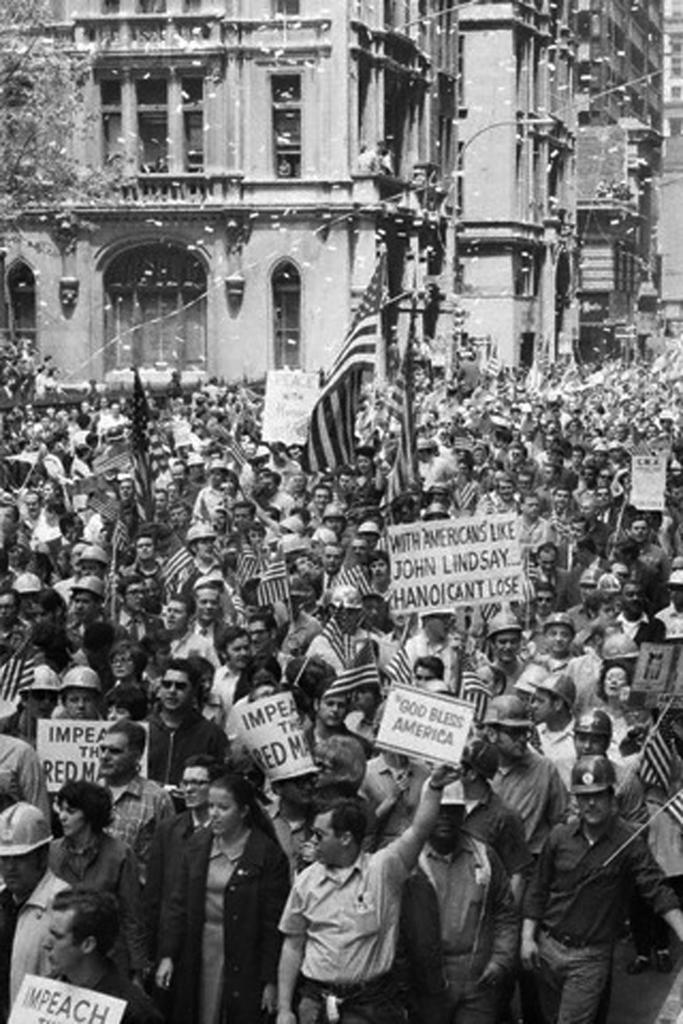What is the color scheme of the image? The image is black and white. What can be seen in the image? There is a group of people in the image. What are the people doing in the image? The people are standing and holding flags and placards. What is visible in the background of the image? There are buildings in the background of the image. How much dirt is visible on the people's shoes in the image? There is no dirt visible on the people's shoes in the image, as it is a black and white image and dirt would not be discernible. 